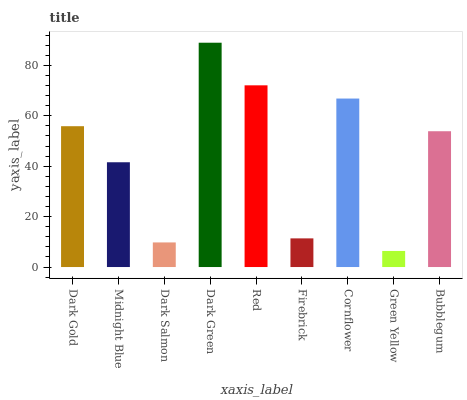Is Midnight Blue the minimum?
Answer yes or no. No. Is Midnight Blue the maximum?
Answer yes or no. No. Is Dark Gold greater than Midnight Blue?
Answer yes or no. Yes. Is Midnight Blue less than Dark Gold?
Answer yes or no. Yes. Is Midnight Blue greater than Dark Gold?
Answer yes or no. No. Is Dark Gold less than Midnight Blue?
Answer yes or no. No. Is Bubblegum the high median?
Answer yes or no. Yes. Is Bubblegum the low median?
Answer yes or no. Yes. Is Cornflower the high median?
Answer yes or no. No. Is Dark Green the low median?
Answer yes or no. No. 